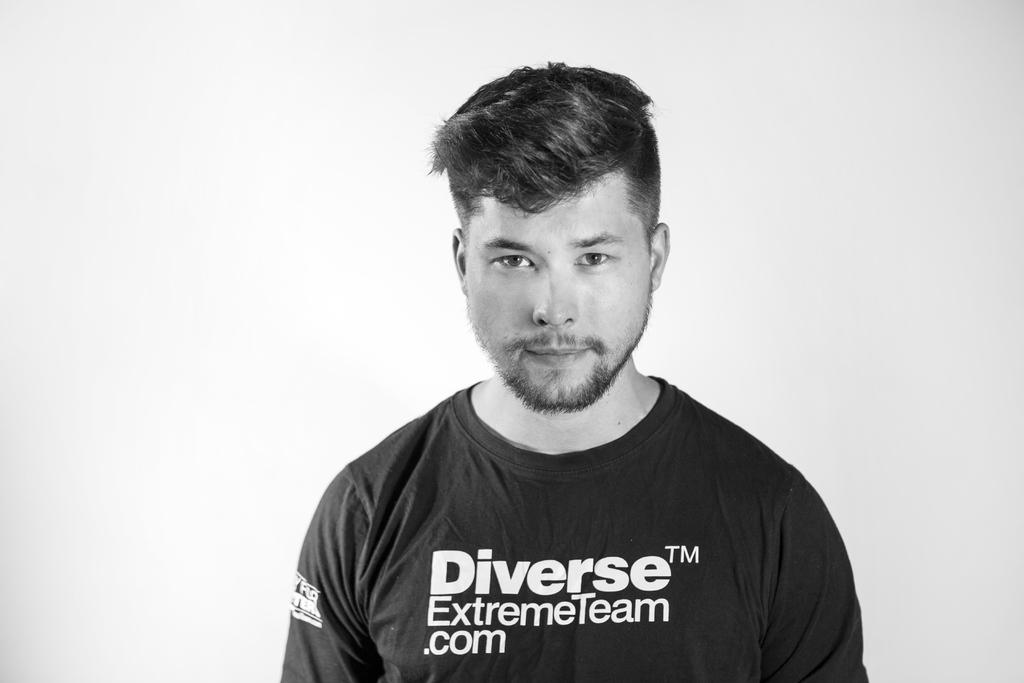What is the color scheme of the image? The image is black and white. Can you describe the main subject of the image? There is a person in the image. What is the person doing in the image? The person is standing. What color is the background of the image? The background of the image is white. What type of cabbage is being harvested in the image? There is no cabbage present in the image; it is a black and white image of a person standing against a white background. 